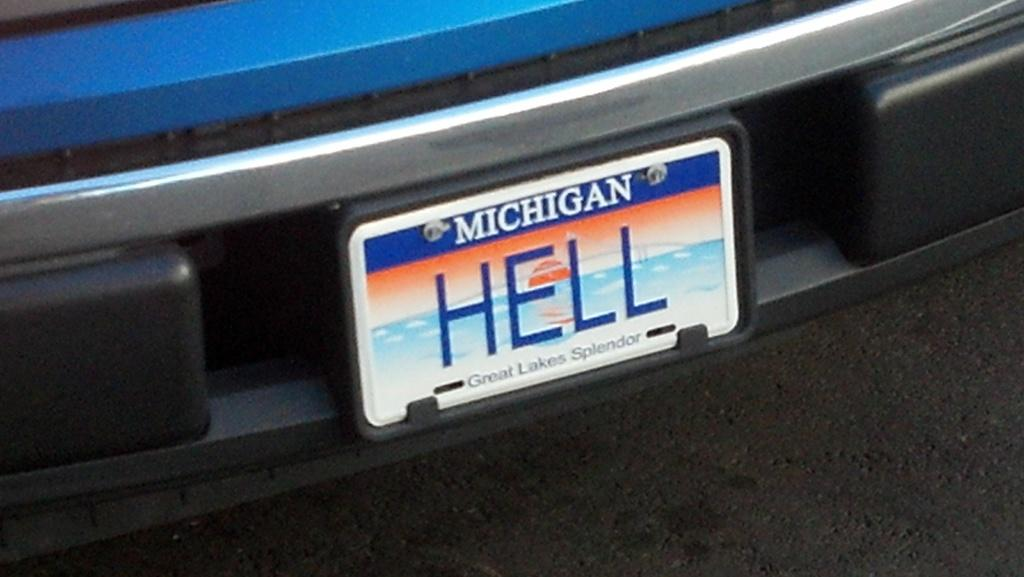<image>
Render a clear and concise summary of the photo. The bumper of a blue car with a Michigan tag on it that says Hell. 